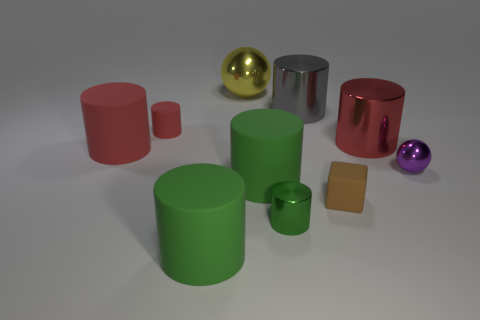Subtract all blue cubes. How many green cylinders are left? 3 Subtract all gray cylinders. How many cylinders are left? 6 Subtract all small matte cylinders. How many cylinders are left? 6 Subtract all purple cylinders. Subtract all red spheres. How many cylinders are left? 7 Subtract all cylinders. How many objects are left? 3 Add 5 small yellow metal things. How many small yellow metal things exist? 5 Subtract 0 brown cylinders. How many objects are left? 10 Subtract all gray things. Subtract all big yellow metal spheres. How many objects are left? 8 Add 6 large rubber objects. How many large rubber objects are left? 9 